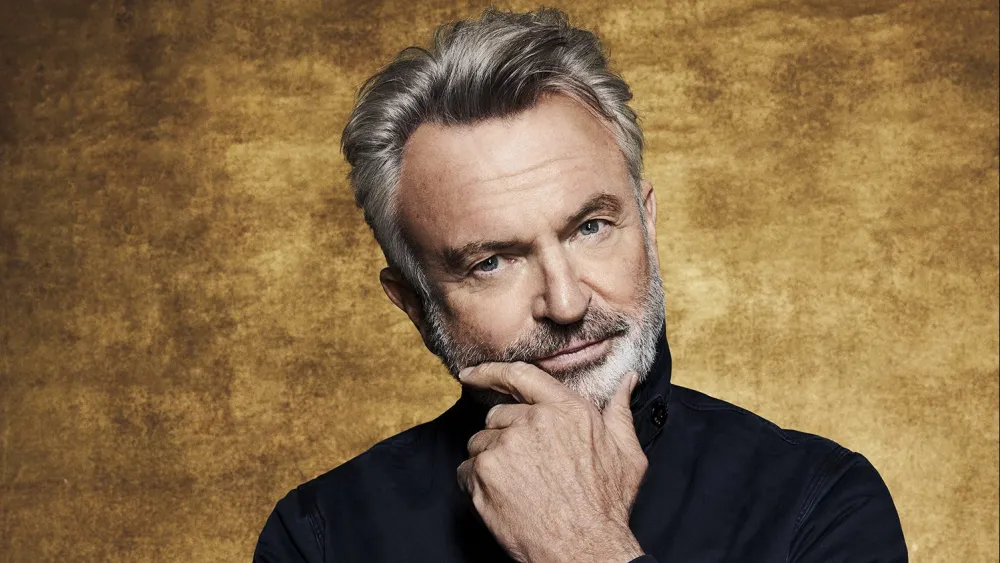What do you see happening in this image? In this image, a distinguished gentleman with gray hair and a beard is captured in a thoughtful pose against a gold background. He is dressed in a black shirt, which contrasts well with the warm tones of the backdrop. His hand is gently resting on his chin, suggesting a moment of contemplation or introspection. A slight smile is visible on his face, hinting at a sense of contentment or amusement. The overall composition of the image, including the lighting and background, emphasizes the subject's thoughtful expression and adds a sense of elegance to the portrait. 